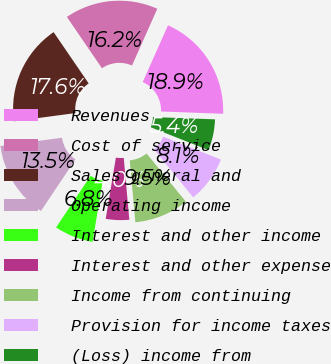<chart> <loc_0><loc_0><loc_500><loc_500><pie_chart><fcel>Revenues<fcel>Cost of service<fcel>Sales general and<fcel>Operating income<fcel>Interest and other income<fcel>Interest and other expense<fcel>Income from continuing<fcel>Provision for income taxes<fcel>(Loss) income from<nl><fcel>18.92%<fcel>16.22%<fcel>17.57%<fcel>13.51%<fcel>6.76%<fcel>4.05%<fcel>9.46%<fcel>8.11%<fcel>5.41%<nl></chart> 